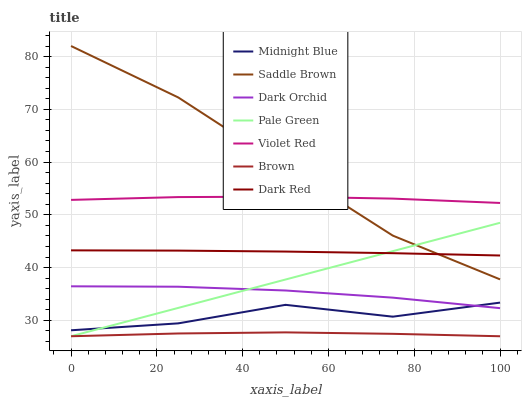Does Violet Red have the minimum area under the curve?
Answer yes or no. No. Does Violet Red have the maximum area under the curve?
Answer yes or no. No. Is Violet Red the smoothest?
Answer yes or no. No. Is Violet Red the roughest?
Answer yes or no. No. Does Midnight Blue have the lowest value?
Answer yes or no. No. Does Violet Red have the highest value?
Answer yes or no. No. Is Brown less than Midnight Blue?
Answer yes or no. Yes. Is Dark Red greater than Dark Orchid?
Answer yes or no. Yes. Does Brown intersect Midnight Blue?
Answer yes or no. No. 